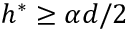Convert formula to latex. <formula><loc_0><loc_0><loc_500><loc_500>h ^ { * } \geq \alpha d / 2</formula> 